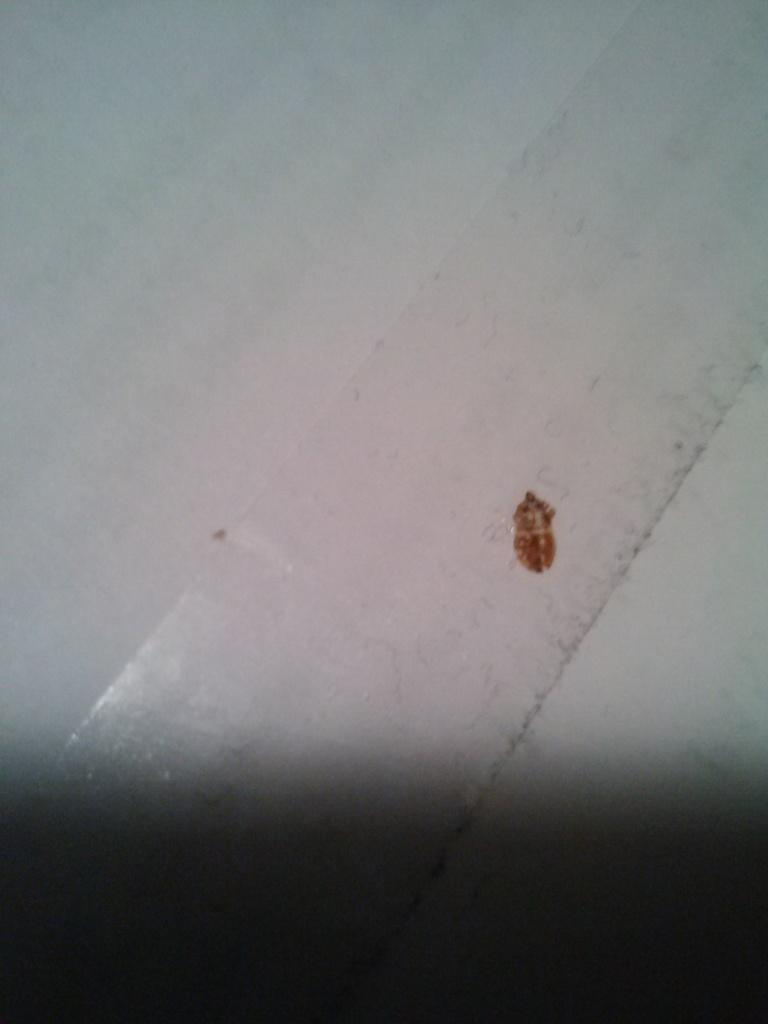What material is the main object in the image made of? The main object in the image is made of wood. What color is the wooden object? The wooden object is painted white. Is there any noticeable mark on the wooden object? Yes, there is a brown color mark on the right side of the plank. What type of food is being protested against in the image? There is no protest or food present in the image; it only features a wooden plank with a brown color mark. How many toes can be seen on the wooden plank in the image? There are no toes visible in the image, as it only features a wooden plank with a brown color mark. 